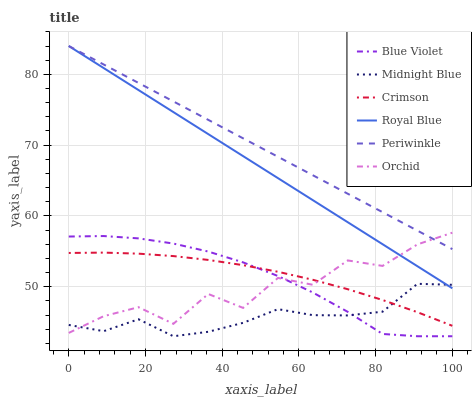Does Midnight Blue have the minimum area under the curve?
Answer yes or no. Yes. Does Periwinkle have the maximum area under the curve?
Answer yes or no. Yes. Does Royal Blue have the minimum area under the curve?
Answer yes or no. No. Does Royal Blue have the maximum area under the curve?
Answer yes or no. No. Is Periwinkle the smoothest?
Answer yes or no. Yes. Is Orchid the roughest?
Answer yes or no. Yes. Is Royal Blue the smoothest?
Answer yes or no. No. Is Royal Blue the roughest?
Answer yes or no. No. Does Midnight Blue have the lowest value?
Answer yes or no. Yes. Does Royal Blue have the lowest value?
Answer yes or no. No. Does Periwinkle have the highest value?
Answer yes or no. Yes. Does Crimson have the highest value?
Answer yes or no. No. Is Midnight Blue less than Periwinkle?
Answer yes or no. Yes. Is Periwinkle greater than Blue Violet?
Answer yes or no. Yes. Does Orchid intersect Blue Violet?
Answer yes or no. Yes. Is Orchid less than Blue Violet?
Answer yes or no. No. Is Orchid greater than Blue Violet?
Answer yes or no. No. Does Midnight Blue intersect Periwinkle?
Answer yes or no. No. 